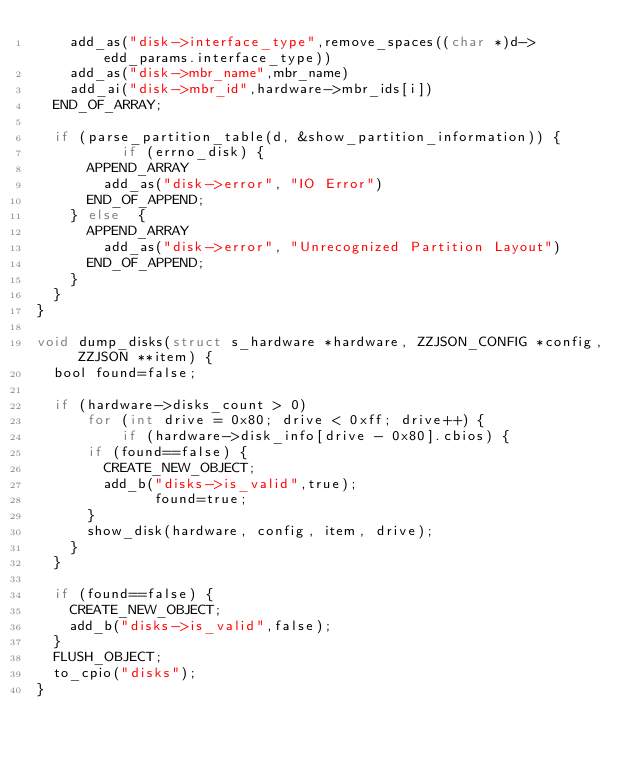<code> <loc_0><loc_0><loc_500><loc_500><_C_>		add_as("disk->interface_type",remove_spaces((char *)d->edd_params.interface_type))
		add_as("disk->mbr_name",mbr_name)
		add_ai("disk->mbr_id",hardware->mbr_ids[i])
	END_OF_ARRAY;

	if (parse_partition_table(d, &show_partition_information)) {
	        if (errno_disk) { 
			APPEND_ARRAY
				add_as("disk->error", "IO Error")
			END_OF_APPEND;
		} else  {
			APPEND_ARRAY
				add_as("disk->error", "Unrecognized Partition Layout")
			END_OF_APPEND;
		}
	}
}

void dump_disks(struct s_hardware *hardware, ZZJSON_CONFIG *config, ZZJSON **item) {
	bool found=false;

 	if (hardware->disks_count > 0)  
	    for (int drive = 0x80; drive < 0xff; drive++) {
	        if (hardware->disk_info[drive - 0x80].cbios) {
			if (found==false) {
				CREATE_NEW_OBJECT;
				add_b("disks->is_valid",true);
       				found=true;
			}
			show_disk(hardware, config, item, drive);
		}
	}

	if (found==false) {
		CREATE_NEW_OBJECT;
		add_b("disks->is_valid",false);
	}
	FLUSH_OBJECT;
	to_cpio("disks");
}
</code> 